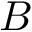Convert formula to latex. <formula><loc_0><loc_0><loc_500><loc_500>B</formula> 